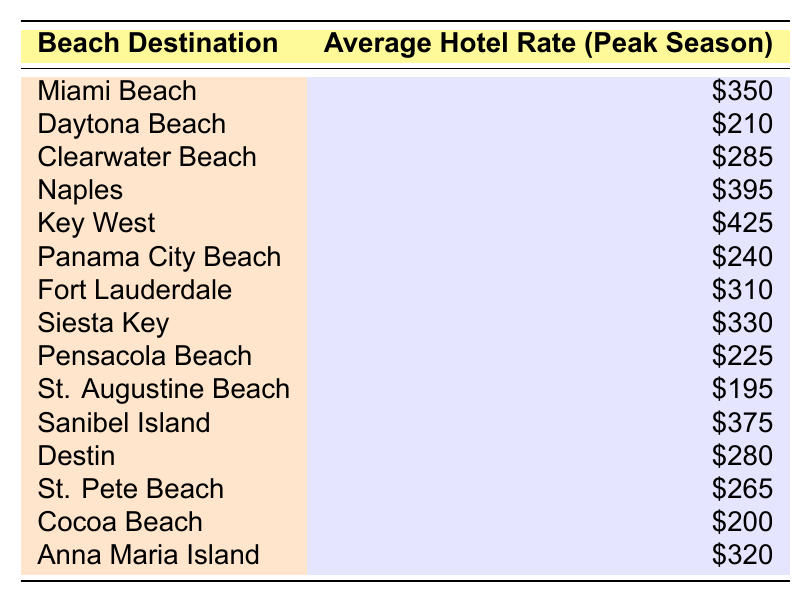What is the average hotel rate in Key West? According to the table, the value listed for Key West is $425.
Answer: $425 Which destination has the lowest average hotel rate? The table shows that St. Augustine Beach has the lowest rate at $195.
Answer: $195 What is the average hotel rate for destinations starting with 'S'? The rates for Siesta Key and St. Pete Beach are $330 and $265, respectively. Adding these together gives $330 + $265 = $595. There are 2 destinations, so the average is $595 / 2 = $297.5.
Answer: $297.5 Is the average hotel rate in Naples higher than that in Daytona Beach? The table indicates Naples at $395 and Daytona Beach at $210. Since $395 is greater than $210, the answer is yes.
Answer: Yes What is the total hotel rate for all destinations listed in the table? The average hotel rates for the listed destinations are: $350 + $210 + $285 + $395 + $425 + $240 + $310 + $330 + $225 + $195 + $375 + $280 + $265 + $200 + $320 = $4,045.
Answer: $4,045 How many beach destinations have an average hotel rate above $300? Looking at the table, the destinations with rates above $300 are Miami Beach ($350), Naples ($395), Key West ($425), Fort Lauderdale ($310), Siesta Key ($330), and Sanibel Island ($375). That totals 6 destinations.
Answer: 6 What is the difference in average hotel rates between the most expensive and least expensive destinations? Key West at $425 is the most expensive, and St. Augustine Beach at $195 is the least expensive. The difference is $425 - $195 = $230.
Answer: $230 Which destination has a higher average hotel rate, Cocoa Beach or Panama City Beach? Cocoa Beach has an average rate of $200, while Panama City Beach has $240. Since $240 is higher, Panama City Beach has a higher rate.
Answer: Panama City Beach List the average hotel rates for Anna Maria Island and Clearwater Beach. Anna Maria Island is $320 and Clearwater Beach is $285, as stated in the table.
Answer: Anna Maria Island: $320, Clearwater Beach: $285 How does the average hotel rate of St. Pete Beach compare to that of Pensacola Beach? St. Pete Beach has a rate of $265, while Pensacola Beach has $225. Since $265 is greater than $225, St. Pete Beach is higher.
Answer: St. Pete Beach is higher 